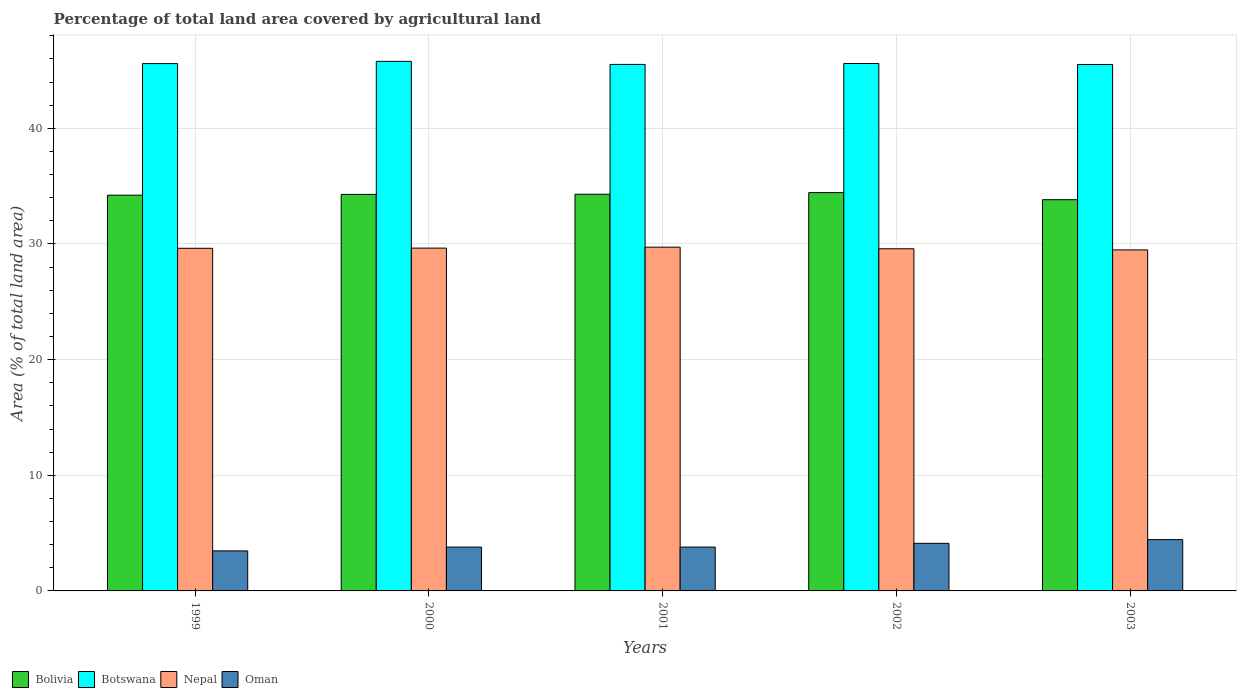How many different coloured bars are there?
Your answer should be very brief. 4. How many bars are there on the 4th tick from the left?
Offer a terse response. 4. How many bars are there on the 1st tick from the right?
Keep it short and to the point. 4. In how many cases, is the number of bars for a given year not equal to the number of legend labels?
Provide a short and direct response. 0. What is the percentage of agricultural land in Oman in 2000?
Give a very brief answer. 3.79. Across all years, what is the maximum percentage of agricultural land in Botswana?
Offer a terse response. 45.79. Across all years, what is the minimum percentage of agricultural land in Nepal?
Your answer should be compact. 29.49. What is the total percentage of agricultural land in Bolivia in the graph?
Your answer should be very brief. 171.08. What is the difference between the percentage of agricultural land in Oman in 2001 and that in 2003?
Provide a short and direct response. -0.64. What is the difference between the percentage of agricultural land in Botswana in 2003 and the percentage of agricultural land in Oman in 1999?
Provide a short and direct response. 42.06. What is the average percentage of agricultural land in Oman per year?
Give a very brief answer. 3.92. In the year 2002, what is the difference between the percentage of agricultural land in Bolivia and percentage of agricultural land in Botswana?
Your response must be concise. -11.16. What is the ratio of the percentage of agricultural land in Bolivia in 2000 to that in 2001?
Offer a terse response. 1. Is the percentage of agricultural land in Botswana in 2001 less than that in 2003?
Provide a short and direct response. No. What is the difference between the highest and the second highest percentage of agricultural land in Oman?
Keep it short and to the point. 0.32. What is the difference between the highest and the lowest percentage of agricultural land in Botswana?
Make the answer very short. 0.27. In how many years, is the percentage of agricultural land in Botswana greater than the average percentage of agricultural land in Botswana taken over all years?
Your answer should be compact. 1. What does the 2nd bar from the left in 1999 represents?
Offer a very short reply. Botswana. What does the 3rd bar from the right in 1999 represents?
Your answer should be very brief. Botswana. Is it the case that in every year, the sum of the percentage of agricultural land in Botswana and percentage of agricultural land in Bolivia is greater than the percentage of agricultural land in Oman?
Offer a terse response. Yes. Are all the bars in the graph horizontal?
Make the answer very short. No. How many years are there in the graph?
Your response must be concise. 5. Does the graph contain any zero values?
Give a very brief answer. No. Does the graph contain grids?
Your response must be concise. Yes. How many legend labels are there?
Provide a short and direct response. 4. How are the legend labels stacked?
Keep it short and to the point. Horizontal. What is the title of the graph?
Your response must be concise. Percentage of total land area covered by agricultural land. Does "Slovak Republic" appear as one of the legend labels in the graph?
Your answer should be very brief. No. What is the label or title of the Y-axis?
Offer a terse response. Area (% of total land area). What is the Area (% of total land area) of Bolivia in 1999?
Make the answer very short. 34.22. What is the Area (% of total land area) of Botswana in 1999?
Your answer should be very brief. 45.6. What is the Area (% of total land area) in Nepal in 1999?
Your answer should be compact. 29.63. What is the Area (% of total land area) in Oman in 1999?
Your answer should be compact. 3.46. What is the Area (% of total land area) of Bolivia in 2000?
Provide a short and direct response. 34.29. What is the Area (% of total land area) in Botswana in 2000?
Provide a short and direct response. 45.79. What is the Area (% of total land area) of Nepal in 2000?
Provide a short and direct response. 29.64. What is the Area (% of total land area) in Oman in 2000?
Give a very brief answer. 3.79. What is the Area (% of total land area) in Bolivia in 2001?
Give a very brief answer. 34.3. What is the Area (% of total land area) of Botswana in 2001?
Offer a very short reply. 45.53. What is the Area (% of total land area) of Nepal in 2001?
Make the answer very short. 29.72. What is the Area (% of total land area) in Oman in 2001?
Ensure brevity in your answer.  3.79. What is the Area (% of total land area) of Bolivia in 2002?
Your response must be concise. 34.44. What is the Area (% of total land area) in Botswana in 2002?
Your answer should be very brief. 45.61. What is the Area (% of total land area) of Nepal in 2002?
Offer a very short reply. 29.58. What is the Area (% of total land area) of Oman in 2002?
Your answer should be compact. 4.11. What is the Area (% of total land area) of Bolivia in 2003?
Provide a succinct answer. 33.83. What is the Area (% of total land area) of Botswana in 2003?
Ensure brevity in your answer.  45.52. What is the Area (% of total land area) of Nepal in 2003?
Provide a succinct answer. 29.49. What is the Area (% of total land area) of Oman in 2003?
Your answer should be very brief. 4.44. Across all years, what is the maximum Area (% of total land area) of Bolivia?
Provide a short and direct response. 34.44. Across all years, what is the maximum Area (% of total land area) of Botswana?
Provide a succinct answer. 45.79. Across all years, what is the maximum Area (% of total land area) of Nepal?
Ensure brevity in your answer.  29.72. Across all years, what is the maximum Area (% of total land area) in Oman?
Make the answer very short. 4.44. Across all years, what is the minimum Area (% of total land area) in Bolivia?
Offer a very short reply. 33.83. Across all years, what is the minimum Area (% of total land area) in Botswana?
Your response must be concise. 45.52. Across all years, what is the minimum Area (% of total land area) in Nepal?
Provide a short and direct response. 29.49. Across all years, what is the minimum Area (% of total land area) in Oman?
Give a very brief answer. 3.46. What is the total Area (% of total land area) of Bolivia in the graph?
Give a very brief answer. 171.08. What is the total Area (% of total land area) of Botswana in the graph?
Your answer should be compact. 228.04. What is the total Area (% of total land area) in Nepal in the graph?
Give a very brief answer. 148.06. What is the total Area (% of total land area) in Oman in the graph?
Keep it short and to the point. 19.59. What is the difference between the Area (% of total land area) in Bolivia in 1999 and that in 2000?
Your response must be concise. -0.07. What is the difference between the Area (% of total land area) in Botswana in 1999 and that in 2000?
Provide a succinct answer. -0.19. What is the difference between the Area (% of total land area) of Nepal in 1999 and that in 2000?
Offer a terse response. -0.01. What is the difference between the Area (% of total land area) of Oman in 1999 and that in 2000?
Keep it short and to the point. -0.33. What is the difference between the Area (% of total land area) of Bolivia in 1999 and that in 2001?
Your response must be concise. -0.08. What is the difference between the Area (% of total land area) of Botswana in 1999 and that in 2001?
Provide a succinct answer. 0.07. What is the difference between the Area (% of total land area) of Nepal in 1999 and that in 2001?
Make the answer very short. -0.1. What is the difference between the Area (% of total land area) in Oman in 1999 and that in 2001?
Make the answer very short. -0.33. What is the difference between the Area (% of total land area) in Bolivia in 1999 and that in 2002?
Keep it short and to the point. -0.22. What is the difference between the Area (% of total land area) in Botswana in 1999 and that in 2002?
Keep it short and to the point. -0.01. What is the difference between the Area (% of total land area) of Nepal in 1999 and that in 2002?
Provide a succinct answer. 0.04. What is the difference between the Area (% of total land area) in Oman in 1999 and that in 2002?
Your response must be concise. -0.65. What is the difference between the Area (% of total land area) of Bolivia in 1999 and that in 2003?
Your response must be concise. 0.39. What is the difference between the Area (% of total land area) of Botswana in 1999 and that in 2003?
Offer a terse response. 0.08. What is the difference between the Area (% of total land area) of Nepal in 1999 and that in 2003?
Your answer should be compact. 0.14. What is the difference between the Area (% of total land area) of Oman in 1999 and that in 2003?
Your answer should be compact. -0.98. What is the difference between the Area (% of total land area) in Bolivia in 2000 and that in 2001?
Provide a succinct answer. -0.01. What is the difference between the Area (% of total land area) of Botswana in 2000 and that in 2001?
Provide a succinct answer. 0.26. What is the difference between the Area (% of total land area) of Nepal in 2000 and that in 2001?
Give a very brief answer. -0.08. What is the difference between the Area (% of total land area) in Oman in 2000 and that in 2001?
Your answer should be very brief. -0. What is the difference between the Area (% of total land area) of Bolivia in 2000 and that in 2002?
Offer a terse response. -0.16. What is the difference between the Area (% of total land area) of Botswana in 2000 and that in 2002?
Provide a succinct answer. 0.19. What is the difference between the Area (% of total land area) of Nepal in 2000 and that in 2002?
Provide a short and direct response. 0.06. What is the difference between the Area (% of total land area) of Oman in 2000 and that in 2002?
Your answer should be very brief. -0.32. What is the difference between the Area (% of total land area) of Bolivia in 2000 and that in 2003?
Offer a very short reply. 0.46. What is the difference between the Area (% of total land area) of Botswana in 2000 and that in 2003?
Make the answer very short. 0.27. What is the difference between the Area (% of total land area) of Nepal in 2000 and that in 2003?
Offer a very short reply. 0.15. What is the difference between the Area (% of total land area) in Oman in 2000 and that in 2003?
Offer a very short reply. -0.65. What is the difference between the Area (% of total land area) of Bolivia in 2001 and that in 2002?
Give a very brief answer. -0.14. What is the difference between the Area (% of total land area) of Botswana in 2001 and that in 2002?
Your response must be concise. -0.08. What is the difference between the Area (% of total land area) of Nepal in 2001 and that in 2002?
Your response must be concise. 0.14. What is the difference between the Area (% of total land area) in Oman in 2001 and that in 2002?
Your answer should be compact. -0.32. What is the difference between the Area (% of total land area) in Bolivia in 2001 and that in 2003?
Provide a short and direct response. 0.47. What is the difference between the Area (% of total land area) of Botswana in 2001 and that in 2003?
Your response must be concise. 0.01. What is the difference between the Area (% of total land area) of Nepal in 2001 and that in 2003?
Offer a very short reply. 0.24. What is the difference between the Area (% of total land area) of Oman in 2001 and that in 2003?
Ensure brevity in your answer.  -0.64. What is the difference between the Area (% of total land area) in Bolivia in 2002 and that in 2003?
Offer a terse response. 0.61. What is the difference between the Area (% of total land area) in Botswana in 2002 and that in 2003?
Provide a short and direct response. 0.09. What is the difference between the Area (% of total land area) of Nepal in 2002 and that in 2003?
Offer a very short reply. 0.1. What is the difference between the Area (% of total land area) of Oman in 2002 and that in 2003?
Provide a succinct answer. -0.32. What is the difference between the Area (% of total land area) in Bolivia in 1999 and the Area (% of total land area) in Botswana in 2000?
Offer a terse response. -11.57. What is the difference between the Area (% of total land area) of Bolivia in 1999 and the Area (% of total land area) of Nepal in 2000?
Offer a very short reply. 4.58. What is the difference between the Area (% of total land area) in Bolivia in 1999 and the Area (% of total land area) in Oman in 2000?
Ensure brevity in your answer.  30.43. What is the difference between the Area (% of total land area) in Botswana in 1999 and the Area (% of total land area) in Nepal in 2000?
Your answer should be very brief. 15.96. What is the difference between the Area (% of total land area) in Botswana in 1999 and the Area (% of total land area) in Oman in 2000?
Your answer should be compact. 41.81. What is the difference between the Area (% of total land area) of Nepal in 1999 and the Area (% of total land area) of Oman in 2000?
Give a very brief answer. 25.84. What is the difference between the Area (% of total land area) of Bolivia in 1999 and the Area (% of total land area) of Botswana in 2001?
Your answer should be compact. -11.31. What is the difference between the Area (% of total land area) in Bolivia in 1999 and the Area (% of total land area) in Nepal in 2001?
Keep it short and to the point. 4.49. What is the difference between the Area (% of total land area) in Bolivia in 1999 and the Area (% of total land area) in Oman in 2001?
Ensure brevity in your answer.  30.43. What is the difference between the Area (% of total land area) of Botswana in 1999 and the Area (% of total land area) of Nepal in 2001?
Offer a very short reply. 15.87. What is the difference between the Area (% of total land area) in Botswana in 1999 and the Area (% of total land area) in Oman in 2001?
Your answer should be very brief. 41.8. What is the difference between the Area (% of total land area) of Nepal in 1999 and the Area (% of total land area) of Oman in 2001?
Give a very brief answer. 25.83. What is the difference between the Area (% of total land area) of Bolivia in 1999 and the Area (% of total land area) of Botswana in 2002?
Provide a short and direct response. -11.39. What is the difference between the Area (% of total land area) in Bolivia in 1999 and the Area (% of total land area) in Nepal in 2002?
Provide a succinct answer. 4.63. What is the difference between the Area (% of total land area) in Bolivia in 1999 and the Area (% of total land area) in Oman in 2002?
Offer a terse response. 30.1. What is the difference between the Area (% of total land area) in Botswana in 1999 and the Area (% of total land area) in Nepal in 2002?
Provide a short and direct response. 16.01. What is the difference between the Area (% of total land area) of Botswana in 1999 and the Area (% of total land area) of Oman in 2002?
Your response must be concise. 41.48. What is the difference between the Area (% of total land area) in Nepal in 1999 and the Area (% of total land area) in Oman in 2002?
Your answer should be very brief. 25.51. What is the difference between the Area (% of total land area) of Bolivia in 1999 and the Area (% of total land area) of Botswana in 2003?
Ensure brevity in your answer.  -11.3. What is the difference between the Area (% of total land area) of Bolivia in 1999 and the Area (% of total land area) of Nepal in 2003?
Keep it short and to the point. 4.73. What is the difference between the Area (% of total land area) of Bolivia in 1999 and the Area (% of total land area) of Oman in 2003?
Provide a short and direct response. 29.78. What is the difference between the Area (% of total land area) in Botswana in 1999 and the Area (% of total land area) in Nepal in 2003?
Provide a succinct answer. 16.11. What is the difference between the Area (% of total land area) of Botswana in 1999 and the Area (% of total land area) of Oman in 2003?
Make the answer very short. 41.16. What is the difference between the Area (% of total land area) of Nepal in 1999 and the Area (% of total land area) of Oman in 2003?
Your answer should be very brief. 25.19. What is the difference between the Area (% of total land area) in Bolivia in 2000 and the Area (% of total land area) in Botswana in 2001?
Make the answer very short. -11.24. What is the difference between the Area (% of total land area) in Bolivia in 2000 and the Area (% of total land area) in Nepal in 2001?
Your response must be concise. 4.56. What is the difference between the Area (% of total land area) in Bolivia in 2000 and the Area (% of total land area) in Oman in 2001?
Offer a terse response. 30.5. What is the difference between the Area (% of total land area) in Botswana in 2000 and the Area (% of total land area) in Nepal in 2001?
Offer a terse response. 16.07. What is the difference between the Area (% of total land area) in Botswana in 2000 and the Area (% of total land area) in Oman in 2001?
Offer a very short reply. 42. What is the difference between the Area (% of total land area) of Nepal in 2000 and the Area (% of total land area) of Oman in 2001?
Keep it short and to the point. 25.85. What is the difference between the Area (% of total land area) of Bolivia in 2000 and the Area (% of total land area) of Botswana in 2002?
Offer a terse response. -11.32. What is the difference between the Area (% of total land area) in Bolivia in 2000 and the Area (% of total land area) in Nepal in 2002?
Keep it short and to the point. 4.7. What is the difference between the Area (% of total land area) in Bolivia in 2000 and the Area (% of total land area) in Oman in 2002?
Provide a short and direct response. 30.17. What is the difference between the Area (% of total land area) in Botswana in 2000 and the Area (% of total land area) in Nepal in 2002?
Give a very brief answer. 16.21. What is the difference between the Area (% of total land area) in Botswana in 2000 and the Area (% of total land area) in Oman in 2002?
Offer a very short reply. 41.68. What is the difference between the Area (% of total land area) of Nepal in 2000 and the Area (% of total land area) of Oman in 2002?
Offer a terse response. 25.53. What is the difference between the Area (% of total land area) of Bolivia in 2000 and the Area (% of total land area) of Botswana in 2003?
Your answer should be very brief. -11.23. What is the difference between the Area (% of total land area) of Bolivia in 2000 and the Area (% of total land area) of Nepal in 2003?
Your response must be concise. 4.8. What is the difference between the Area (% of total land area) in Bolivia in 2000 and the Area (% of total land area) in Oman in 2003?
Ensure brevity in your answer.  29.85. What is the difference between the Area (% of total land area) of Botswana in 2000 and the Area (% of total land area) of Nepal in 2003?
Keep it short and to the point. 16.3. What is the difference between the Area (% of total land area) in Botswana in 2000 and the Area (% of total land area) in Oman in 2003?
Your answer should be compact. 41.35. What is the difference between the Area (% of total land area) in Nepal in 2000 and the Area (% of total land area) in Oman in 2003?
Ensure brevity in your answer.  25.21. What is the difference between the Area (% of total land area) of Bolivia in 2001 and the Area (% of total land area) of Botswana in 2002?
Your response must be concise. -11.31. What is the difference between the Area (% of total land area) of Bolivia in 2001 and the Area (% of total land area) of Nepal in 2002?
Your answer should be compact. 4.71. What is the difference between the Area (% of total land area) in Bolivia in 2001 and the Area (% of total land area) in Oman in 2002?
Offer a very short reply. 30.18. What is the difference between the Area (% of total land area) of Botswana in 2001 and the Area (% of total land area) of Nepal in 2002?
Make the answer very short. 15.94. What is the difference between the Area (% of total land area) of Botswana in 2001 and the Area (% of total land area) of Oman in 2002?
Keep it short and to the point. 41.41. What is the difference between the Area (% of total land area) of Nepal in 2001 and the Area (% of total land area) of Oman in 2002?
Your answer should be compact. 25.61. What is the difference between the Area (% of total land area) in Bolivia in 2001 and the Area (% of total land area) in Botswana in 2003?
Provide a short and direct response. -11.22. What is the difference between the Area (% of total land area) of Bolivia in 2001 and the Area (% of total land area) of Nepal in 2003?
Offer a very short reply. 4.81. What is the difference between the Area (% of total land area) in Bolivia in 2001 and the Area (% of total land area) in Oman in 2003?
Your answer should be compact. 29.86. What is the difference between the Area (% of total land area) of Botswana in 2001 and the Area (% of total land area) of Nepal in 2003?
Offer a terse response. 16.04. What is the difference between the Area (% of total land area) of Botswana in 2001 and the Area (% of total land area) of Oman in 2003?
Give a very brief answer. 41.09. What is the difference between the Area (% of total land area) of Nepal in 2001 and the Area (% of total land area) of Oman in 2003?
Keep it short and to the point. 25.29. What is the difference between the Area (% of total land area) in Bolivia in 2002 and the Area (% of total land area) in Botswana in 2003?
Your response must be concise. -11.08. What is the difference between the Area (% of total land area) in Bolivia in 2002 and the Area (% of total land area) in Nepal in 2003?
Offer a very short reply. 4.95. What is the difference between the Area (% of total land area) in Bolivia in 2002 and the Area (% of total land area) in Oman in 2003?
Provide a short and direct response. 30.01. What is the difference between the Area (% of total land area) in Botswana in 2002 and the Area (% of total land area) in Nepal in 2003?
Make the answer very short. 16.12. What is the difference between the Area (% of total land area) of Botswana in 2002 and the Area (% of total land area) of Oman in 2003?
Your answer should be very brief. 41.17. What is the difference between the Area (% of total land area) of Nepal in 2002 and the Area (% of total land area) of Oman in 2003?
Provide a short and direct response. 25.15. What is the average Area (% of total land area) in Bolivia per year?
Keep it short and to the point. 34.22. What is the average Area (% of total land area) of Botswana per year?
Keep it short and to the point. 45.61. What is the average Area (% of total land area) in Nepal per year?
Your answer should be compact. 29.61. What is the average Area (% of total land area) in Oman per year?
Offer a terse response. 3.92. In the year 1999, what is the difference between the Area (% of total land area) of Bolivia and Area (% of total land area) of Botswana?
Give a very brief answer. -11.38. In the year 1999, what is the difference between the Area (% of total land area) in Bolivia and Area (% of total land area) in Nepal?
Offer a terse response. 4.59. In the year 1999, what is the difference between the Area (% of total land area) in Bolivia and Area (% of total land area) in Oman?
Give a very brief answer. 30.76. In the year 1999, what is the difference between the Area (% of total land area) of Botswana and Area (% of total land area) of Nepal?
Your answer should be very brief. 15.97. In the year 1999, what is the difference between the Area (% of total land area) in Botswana and Area (% of total land area) in Oman?
Your answer should be compact. 42.14. In the year 1999, what is the difference between the Area (% of total land area) of Nepal and Area (% of total land area) of Oman?
Provide a succinct answer. 26.17. In the year 2000, what is the difference between the Area (% of total land area) of Bolivia and Area (% of total land area) of Botswana?
Your response must be concise. -11.5. In the year 2000, what is the difference between the Area (% of total land area) in Bolivia and Area (% of total land area) in Nepal?
Your answer should be very brief. 4.65. In the year 2000, what is the difference between the Area (% of total land area) of Bolivia and Area (% of total land area) of Oman?
Your response must be concise. 30.5. In the year 2000, what is the difference between the Area (% of total land area) in Botswana and Area (% of total land area) in Nepal?
Offer a terse response. 16.15. In the year 2000, what is the difference between the Area (% of total land area) of Botswana and Area (% of total land area) of Oman?
Your response must be concise. 42. In the year 2000, what is the difference between the Area (% of total land area) of Nepal and Area (% of total land area) of Oman?
Ensure brevity in your answer.  25.85. In the year 2001, what is the difference between the Area (% of total land area) in Bolivia and Area (% of total land area) in Botswana?
Give a very brief answer. -11.23. In the year 2001, what is the difference between the Area (% of total land area) of Bolivia and Area (% of total land area) of Nepal?
Offer a very short reply. 4.57. In the year 2001, what is the difference between the Area (% of total land area) in Bolivia and Area (% of total land area) in Oman?
Keep it short and to the point. 30.51. In the year 2001, what is the difference between the Area (% of total land area) of Botswana and Area (% of total land area) of Nepal?
Give a very brief answer. 15.8. In the year 2001, what is the difference between the Area (% of total land area) of Botswana and Area (% of total land area) of Oman?
Keep it short and to the point. 41.73. In the year 2001, what is the difference between the Area (% of total land area) in Nepal and Area (% of total land area) in Oman?
Keep it short and to the point. 25.93. In the year 2002, what is the difference between the Area (% of total land area) of Bolivia and Area (% of total land area) of Botswana?
Ensure brevity in your answer.  -11.16. In the year 2002, what is the difference between the Area (% of total land area) in Bolivia and Area (% of total land area) in Nepal?
Keep it short and to the point. 4.86. In the year 2002, what is the difference between the Area (% of total land area) of Bolivia and Area (% of total land area) of Oman?
Offer a very short reply. 30.33. In the year 2002, what is the difference between the Area (% of total land area) of Botswana and Area (% of total land area) of Nepal?
Give a very brief answer. 16.02. In the year 2002, what is the difference between the Area (% of total land area) of Botswana and Area (% of total land area) of Oman?
Your response must be concise. 41.49. In the year 2002, what is the difference between the Area (% of total land area) of Nepal and Area (% of total land area) of Oman?
Make the answer very short. 25.47. In the year 2003, what is the difference between the Area (% of total land area) of Bolivia and Area (% of total land area) of Botswana?
Your response must be concise. -11.69. In the year 2003, what is the difference between the Area (% of total land area) in Bolivia and Area (% of total land area) in Nepal?
Your answer should be very brief. 4.34. In the year 2003, what is the difference between the Area (% of total land area) of Bolivia and Area (% of total land area) of Oman?
Your response must be concise. 29.39. In the year 2003, what is the difference between the Area (% of total land area) in Botswana and Area (% of total land area) in Nepal?
Offer a very short reply. 16.03. In the year 2003, what is the difference between the Area (% of total land area) of Botswana and Area (% of total land area) of Oman?
Provide a succinct answer. 41.08. In the year 2003, what is the difference between the Area (% of total land area) in Nepal and Area (% of total land area) in Oman?
Your answer should be very brief. 25.05. What is the ratio of the Area (% of total land area) of Bolivia in 1999 to that in 2000?
Give a very brief answer. 1. What is the ratio of the Area (% of total land area) of Botswana in 1999 to that in 2000?
Keep it short and to the point. 1. What is the ratio of the Area (% of total land area) in Nepal in 1999 to that in 2000?
Your answer should be very brief. 1. What is the ratio of the Area (% of total land area) in Oman in 1999 to that in 2000?
Your answer should be compact. 0.91. What is the ratio of the Area (% of total land area) of Bolivia in 1999 to that in 2001?
Your response must be concise. 1. What is the ratio of the Area (% of total land area) in Botswana in 1999 to that in 2001?
Your answer should be compact. 1. What is the ratio of the Area (% of total land area) in Nepal in 1999 to that in 2001?
Your answer should be compact. 1. What is the ratio of the Area (% of total land area) of Oman in 1999 to that in 2001?
Your response must be concise. 0.91. What is the ratio of the Area (% of total land area) of Botswana in 1999 to that in 2002?
Give a very brief answer. 1. What is the ratio of the Area (% of total land area) of Oman in 1999 to that in 2002?
Your answer should be compact. 0.84. What is the ratio of the Area (% of total land area) in Bolivia in 1999 to that in 2003?
Give a very brief answer. 1.01. What is the ratio of the Area (% of total land area) of Botswana in 1999 to that in 2003?
Ensure brevity in your answer.  1. What is the ratio of the Area (% of total land area) of Nepal in 1999 to that in 2003?
Your response must be concise. 1. What is the ratio of the Area (% of total land area) in Oman in 1999 to that in 2003?
Offer a very short reply. 0.78. What is the ratio of the Area (% of total land area) of Bolivia in 2000 to that in 2001?
Keep it short and to the point. 1. What is the ratio of the Area (% of total land area) of Nepal in 2000 to that in 2001?
Give a very brief answer. 1. What is the ratio of the Area (% of total land area) in Oman in 2000 to that in 2001?
Ensure brevity in your answer.  1. What is the ratio of the Area (% of total land area) in Bolivia in 2000 to that in 2002?
Provide a short and direct response. 1. What is the ratio of the Area (% of total land area) in Botswana in 2000 to that in 2002?
Your response must be concise. 1. What is the ratio of the Area (% of total land area) in Nepal in 2000 to that in 2002?
Your answer should be compact. 1. What is the ratio of the Area (% of total land area) in Oman in 2000 to that in 2002?
Your answer should be compact. 0.92. What is the ratio of the Area (% of total land area) of Bolivia in 2000 to that in 2003?
Keep it short and to the point. 1.01. What is the ratio of the Area (% of total land area) of Botswana in 2000 to that in 2003?
Your response must be concise. 1.01. What is the ratio of the Area (% of total land area) in Oman in 2000 to that in 2003?
Ensure brevity in your answer.  0.85. What is the ratio of the Area (% of total land area) of Bolivia in 2001 to that in 2002?
Your answer should be compact. 1. What is the ratio of the Area (% of total land area) in Botswana in 2001 to that in 2002?
Give a very brief answer. 1. What is the ratio of the Area (% of total land area) of Nepal in 2001 to that in 2002?
Keep it short and to the point. 1. What is the ratio of the Area (% of total land area) of Oman in 2001 to that in 2002?
Make the answer very short. 0.92. What is the ratio of the Area (% of total land area) of Bolivia in 2001 to that in 2003?
Keep it short and to the point. 1.01. What is the ratio of the Area (% of total land area) of Oman in 2001 to that in 2003?
Keep it short and to the point. 0.85. What is the ratio of the Area (% of total land area) of Bolivia in 2002 to that in 2003?
Your answer should be very brief. 1.02. What is the ratio of the Area (% of total land area) in Oman in 2002 to that in 2003?
Give a very brief answer. 0.93. What is the difference between the highest and the second highest Area (% of total land area) in Bolivia?
Keep it short and to the point. 0.14. What is the difference between the highest and the second highest Area (% of total land area) of Botswana?
Make the answer very short. 0.19. What is the difference between the highest and the second highest Area (% of total land area) in Nepal?
Ensure brevity in your answer.  0.08. What is the difference between the highest and the second highest Area (% of total land area) of Oman?
Offer a very short reply. 0.32. What is the difference between the highest and the lowest Area (% of total land area) in Bolivia?
Give a very brief answer. 0.61. What is the difference between the highest and the lowest Area (% of total land area) of Botswana?
Offer a terse response. 0.27. What is the difference between the highest and the lowest Area (% of total land area) of Nepal?
Ensure brevity in your answer.  0.24. What is the difference between the highest and the lowest Area (% of total land area) in Oman?
Ensure brevity in your answer.  0.98. 